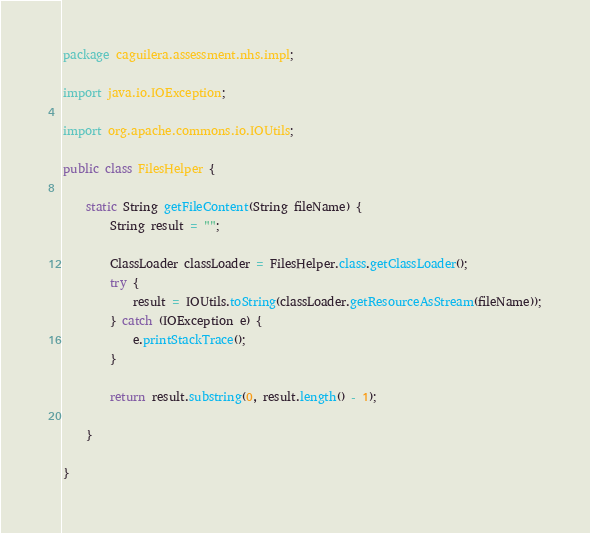Convert code to text. <code><loc_0><loc_0><loc_500><loc_500><_Java_>package caguilera.assessment.nhs.impl;

import java.io.IOException;

import org.apache.commons.io.IOUtils;

public class FilesHelper {

	static String getFileContent(String fileName) {
		String result = "";

		ClassLoader classLoader = FilesHelper.class.getClassLoader();
		try {
			result = IOUtils.toString(classLoader.getResourceAsStream(fileName));
		} catch (IOException e) {
			e.printStackTrace();
		}

		return result.substring(0, result.length() - 1);

	}

}
</code> 